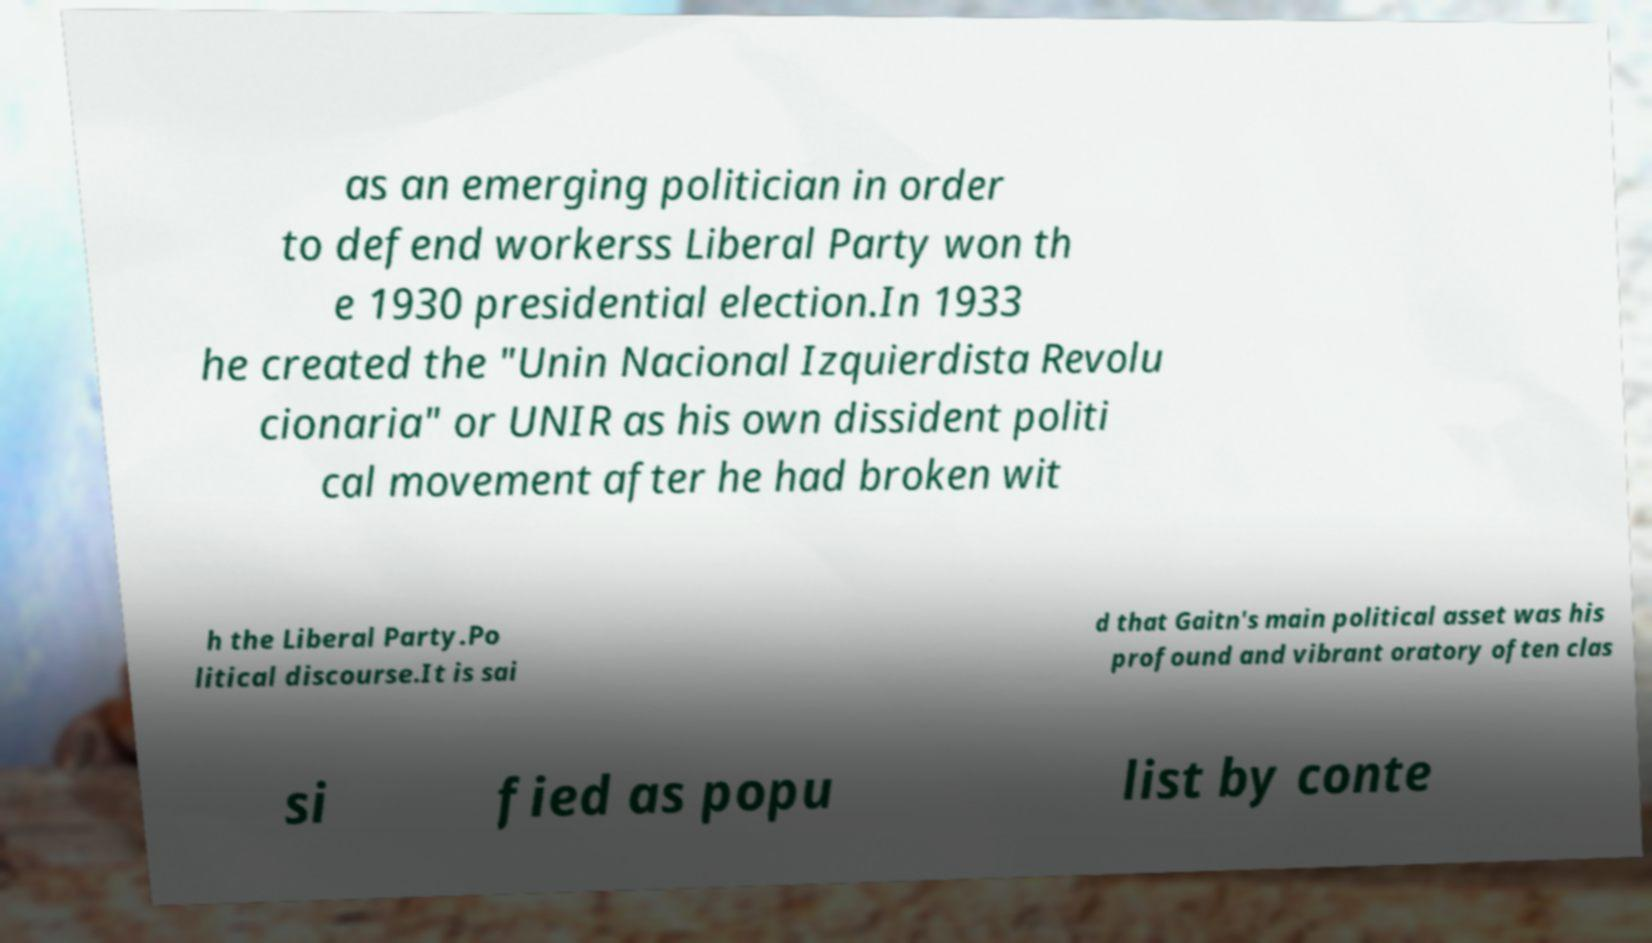Please read and relay the text visible in this image. What does it say? as an emerging politician in order to defend workerss Liberal Party won th e 1930 presidential election.In 1933 he created the "Unin Nacional Izquierdista Revolu cionaria" or UNIR as his own dissident politi cal movement after he had broken wit h the Liberal Party.Po litical discourse.It is sai d that Gaitn's main political asset was his profound and vibrant oratory often clas si fied as popu list by conte 